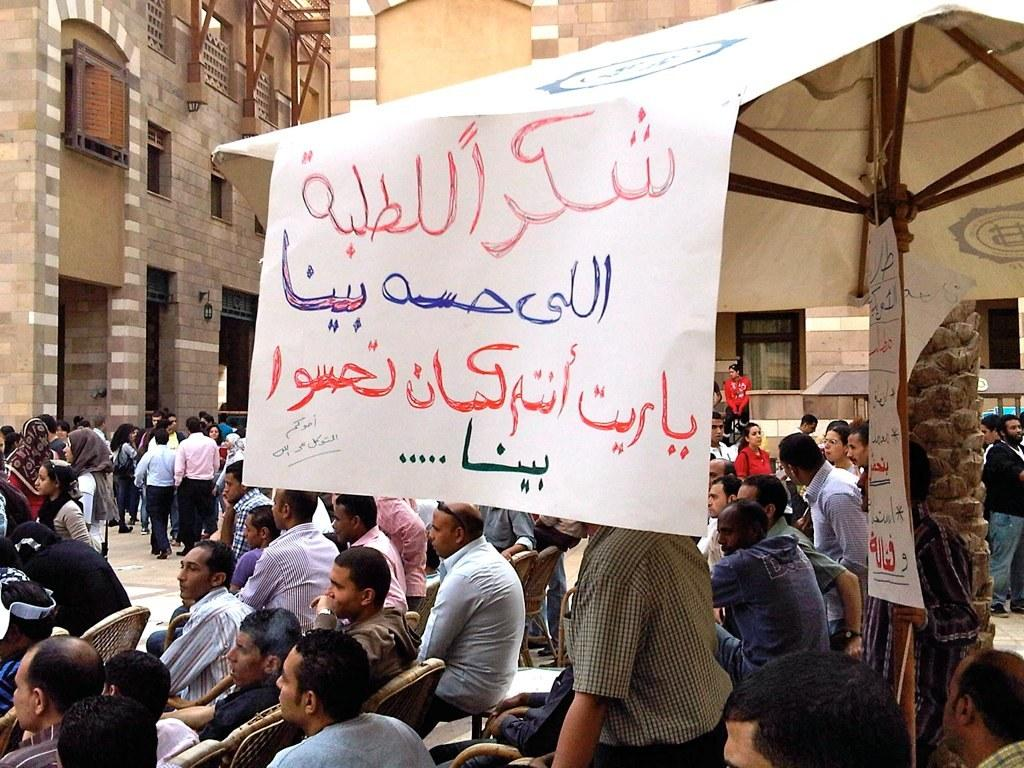What are the people in the image doing? There are people sitting on chairs, standing, and walking in the image. Can you describe the buildings in the background of the image? There are two buildings with windows in the background of the image. How many people are smiling in the image? The provided facts do not mention anyone smiling in the image. --- Facts: 1. There is a person holding a book in the image. 2. The book has a blue cover. 3. The person is sitting on a bench. 4. There is a tree in the background of the image. 5. The sky is visible in the image. Absurd Topics: dance, ocean, parrot Conversation: What is the person in the image holding? The person in the image is holding a book. Can you describe the book's appearance? The book has a blue cover. Where is the person sitting in the image? The person is sitting on a bench. What can be seen in the background of the image? There is a tree in the background of the image. What is visible at the top of the image? The sky is visible in the image. Reasoning: Let's think step by step in order to produce the conversation. We start by identifying the main subject in the image, which is the person holding a book. Then, we describe the book's appearance, including its blue cover. Next, we mention the person's location, which is sitting on a bench. Finally, we describe the background and the sky, which are visible in the image. Each question is designed to elicit a specific detail about the image that is known from the provided facts. Absurd Question/Answer: Can you see any parrots flying over the ocean in the image? There is no ocean or parrots present in the image. 